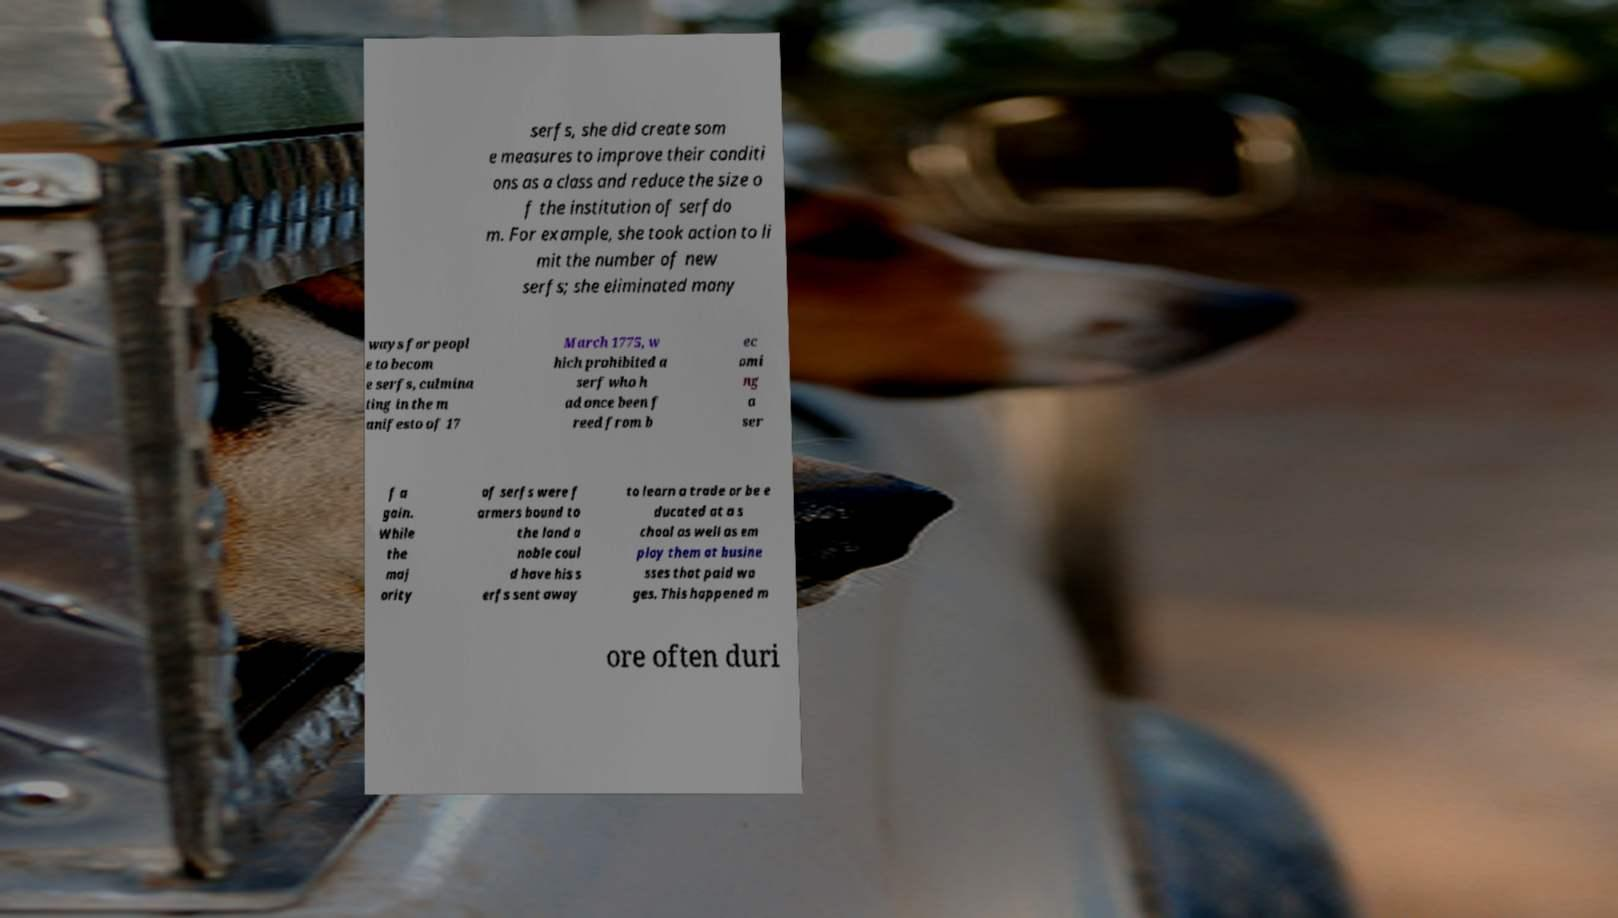I need the written content from this picture converted into text. Can you do that? serfs, she did create som e measures to improve their conditi ons as a class and reduce the size o f the institution of serfdo m. For example, she took action to li mit the number of new serfs; she eliminated many ways for peopl e to becom e serfs, culmina ting in the m anifesto of 17 March 1775, w hich prohibited a serf who h ad once been f reed from b ec omi ng a ser f a gain. While the maj ority of serfs were f armers bound to the land a noble coul d have his s erfs sent away to learn a trade or be e ducated at a s chool as well as em ploy them at busine sses that paid wa ges. This happened m ore often duri 